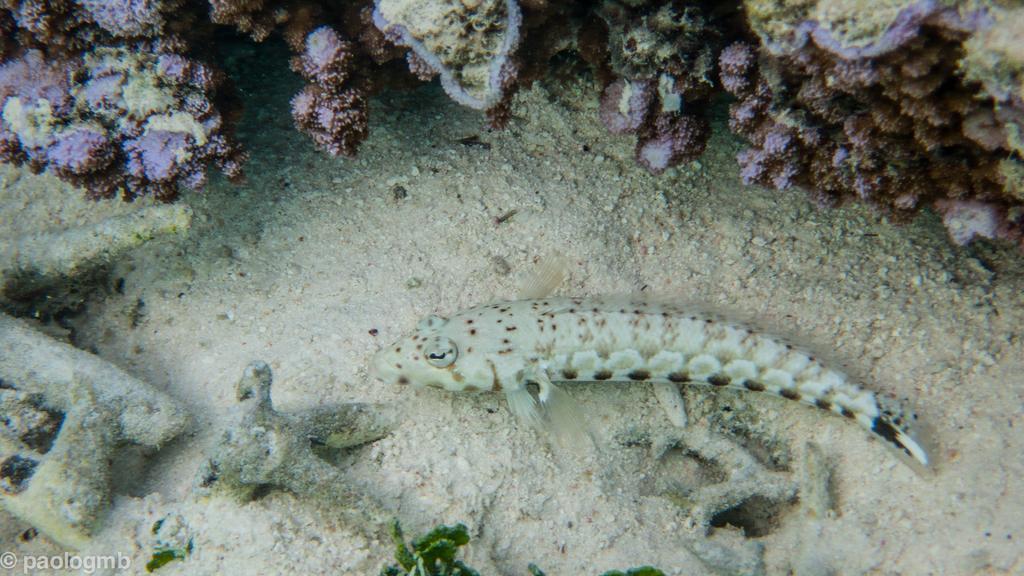Describe this image in one or two sentences. In this image I can see a fish and some sand and other plant species at the bottom of the sea. 